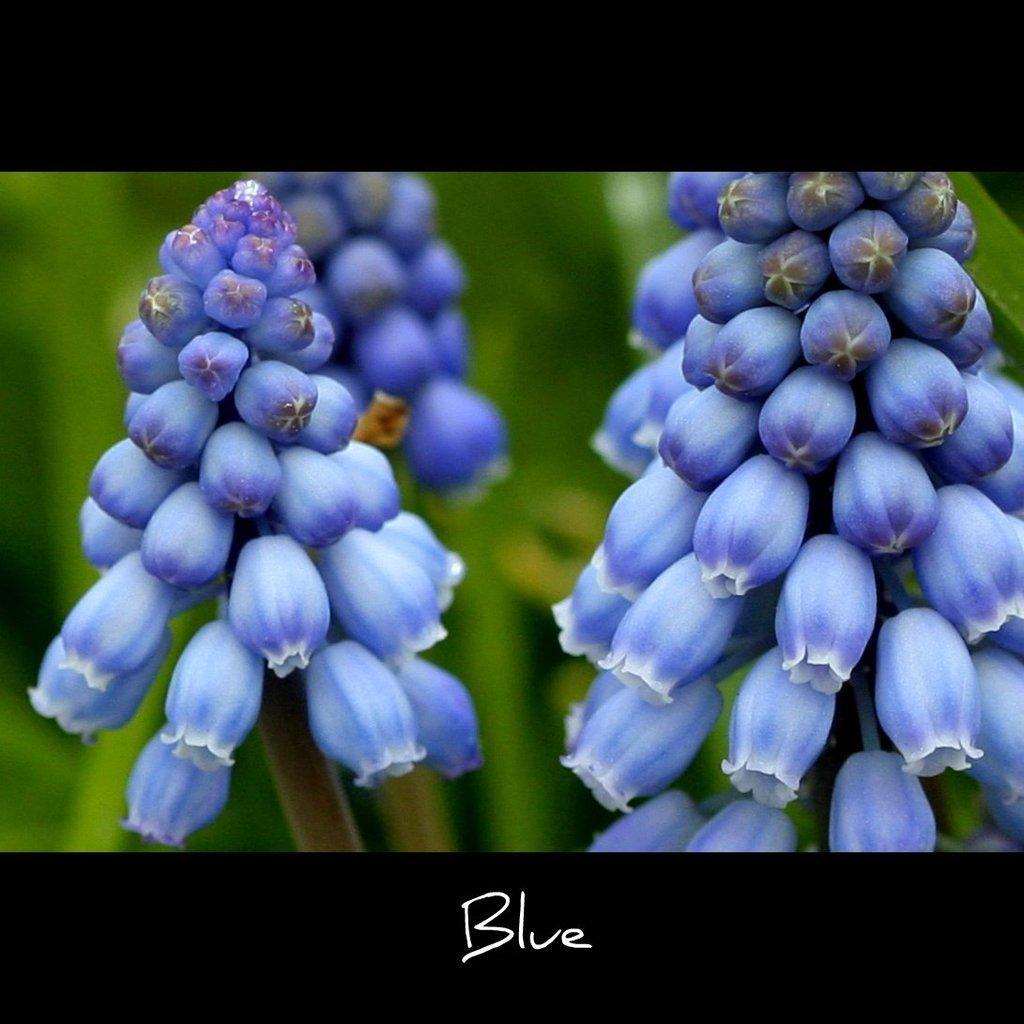How would you summarize this image in a sentence or two? This image consists of flowers in blue color. In the background, we can see the plant. At the bottom, there is a text. 